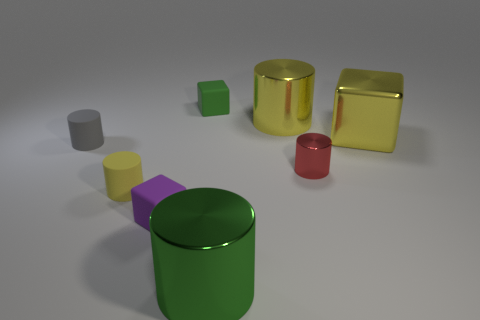What material is the tiny block behind the purple object?
Make the answer very short. Rubber. The gray cylinder has what size?
Offer a very short reply. Small. Do the yellow cylinder on the left side of the purple rubber object and the tiny red object have the same material?
Your answer should be very brief. No. How many red shiny objects are there?
Offer a very short reply. 1. How many objects are either blocks or shiny cylinders?
Keep it short and to the point. 6. There is a yellow thing that is in front of the small cylinder that is on the left side of the yellow rubber cylinder; how many tiny purple cubes are in front of it?
Ensure brevity in your answer.  1. Are there any other things that are the same color as the small shiny cylinder?
Ensure brevity in your answer.  No. There is a block on the right side of the green block; is it the same color as the large cylinder behind the shiny block?
Provide a short and direct response. Yes. Are there more big shiny cylinders that are right of the yellow metal block than red things that are behind the red cylinder?
Provide a succinct answer. No. What is the material of the red cylinder?
Keep it short and to the point. Metal. 